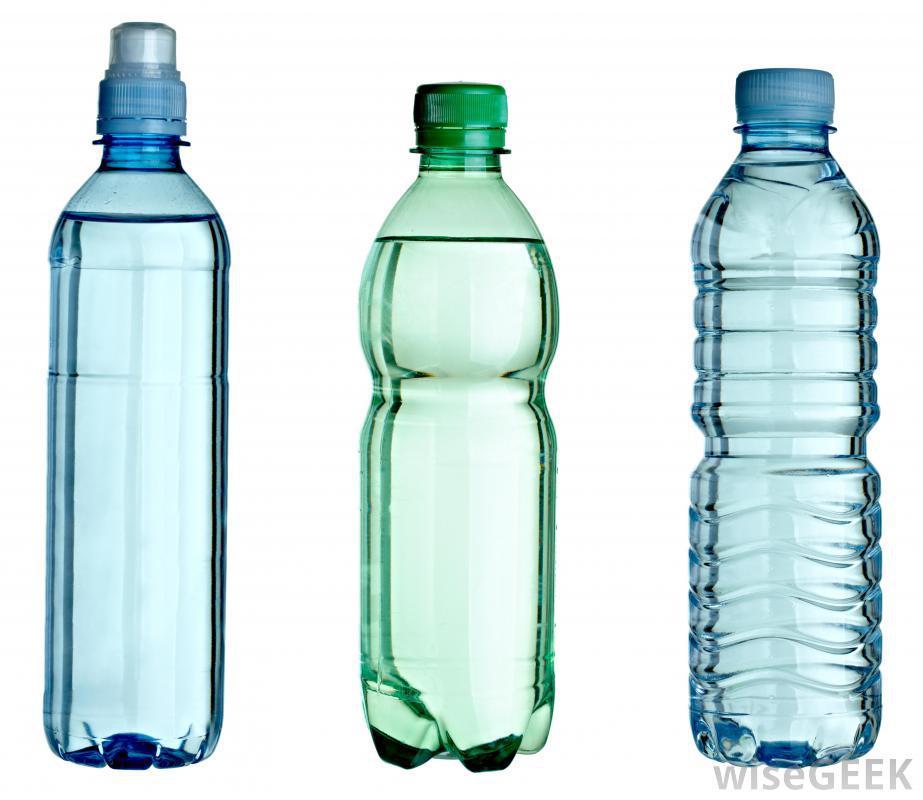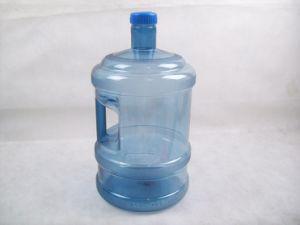The first image is the image on the left, the second image is the image on the right. Given the left and right images, does the statement "There is at least one bottle with fruit and water in it." hold true? Answer yes or no. No. The first image is the image on the left, the second image is the image on the right. Analyze the images presented: Is the assertion "At least one container contains some slices of fruit in it." valid? Answer yes or no. No. 